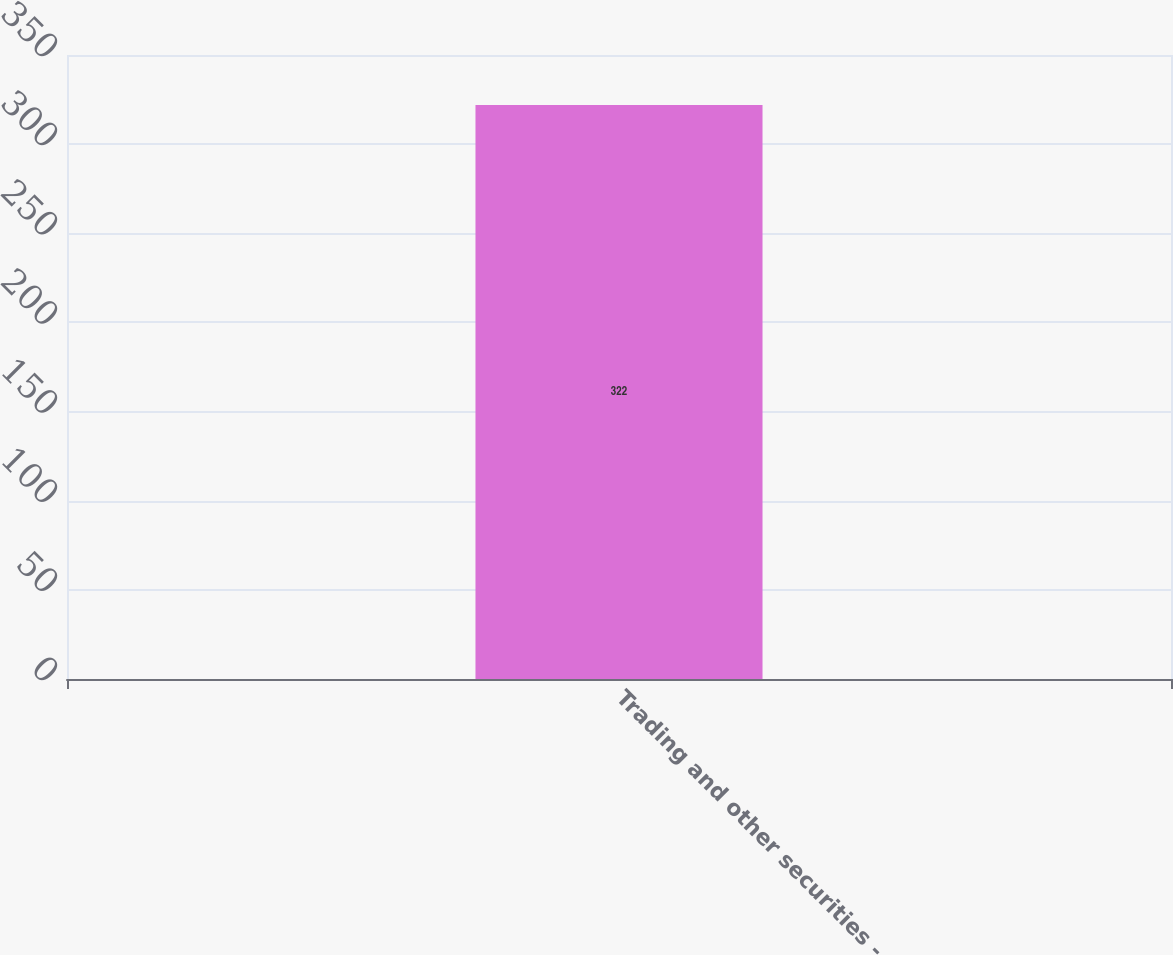Convert chart. <chart><loc_0><loc_0><loc_500><loc_500><bar_chart><fcel>Trading and other securities -<nl><fcel>322<nl></chart> 